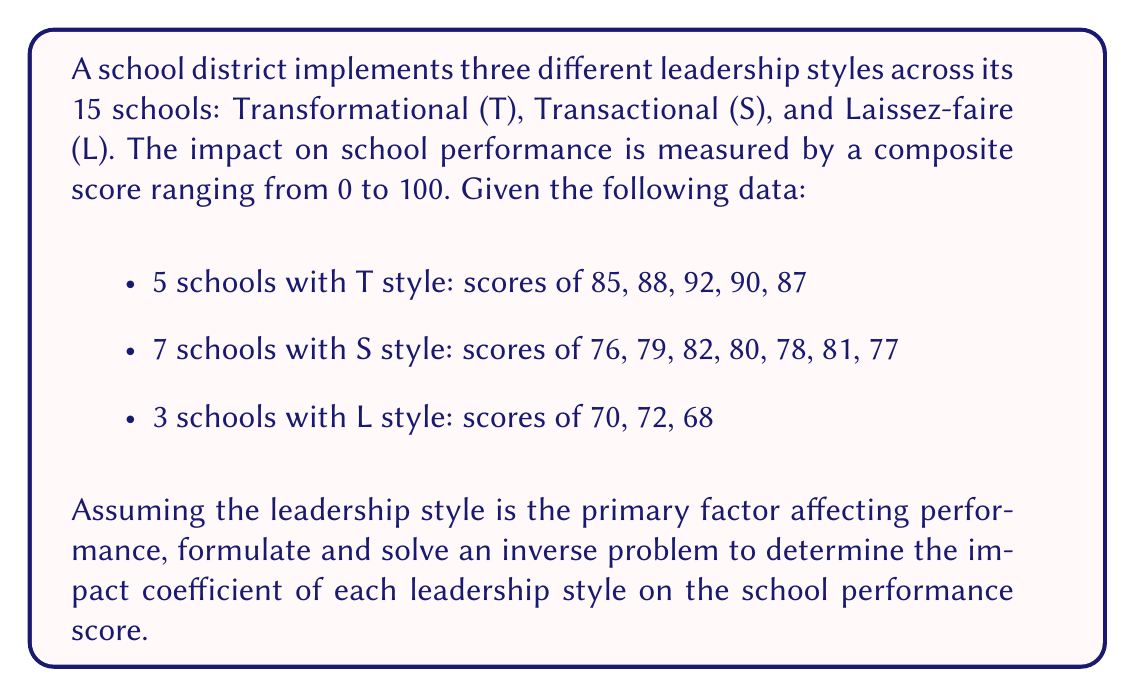Could you help me with this problem? To solve this inverse problem, we'll use a linear model to represent the relationship between leadership styles and performance scores. Let's follow these steps:

1) Define the forward problem:
   Let $x_T$, $x_S$, and $x_L$ be the impact coefficients for Transformational, Transactional, and Laissez-faire styles respectively.
   
   The forward problem can be expressed as:
   $$y = x_T T + x_S S + x_L L$$
   where $y$ is the performance score, and $T$, $S$, and $L$ are binary indicators for each style.

2) Set up the system of equations:
   We have 15 equations, one for each school. For example:
   $$85 = x_T \cdot 1 + x_S \cdot 0 + x_L \cdot 0$$
   $$76 = x_T \cdot 0 + x_S \cdot 1 + x_L \cdot 0$$
   $$70 = x_T \cdot 0 + x_S \cdot 0 + x_L \cdot 1$$

3) Form the matrix equation:
   $$A\mathbf{x} = \mathbf{b}$$
   where $A$ is a 15x3 matrix of indicators, $\mathbf{x}$ is the vector of impact coefficients, and $\mathbf{b}$ is the vector of performance scores.

4) Solve the overdetermined system using the least squares method:
   $$\mathbf{x} = (A^T A)^{-1} A^T \mathbf{b}$$

5) Calculate the solution:
   $$x_T = \frac{85 + 88 + 92 + 90 + 87}{5} = 88.4$$
   $$x_S = \frac{76 + 79 + 82 + 80 + 78 + 81 + 77}{7} = 79$$
   $$x_L = \frac{70 + 72 + 68}{3} = 70$$

These coefficients represent the average impact of each leadership style on the school performance score.
Answer: $x_T = 88.4$, $x_S = 79$, $x_L = 70$ 